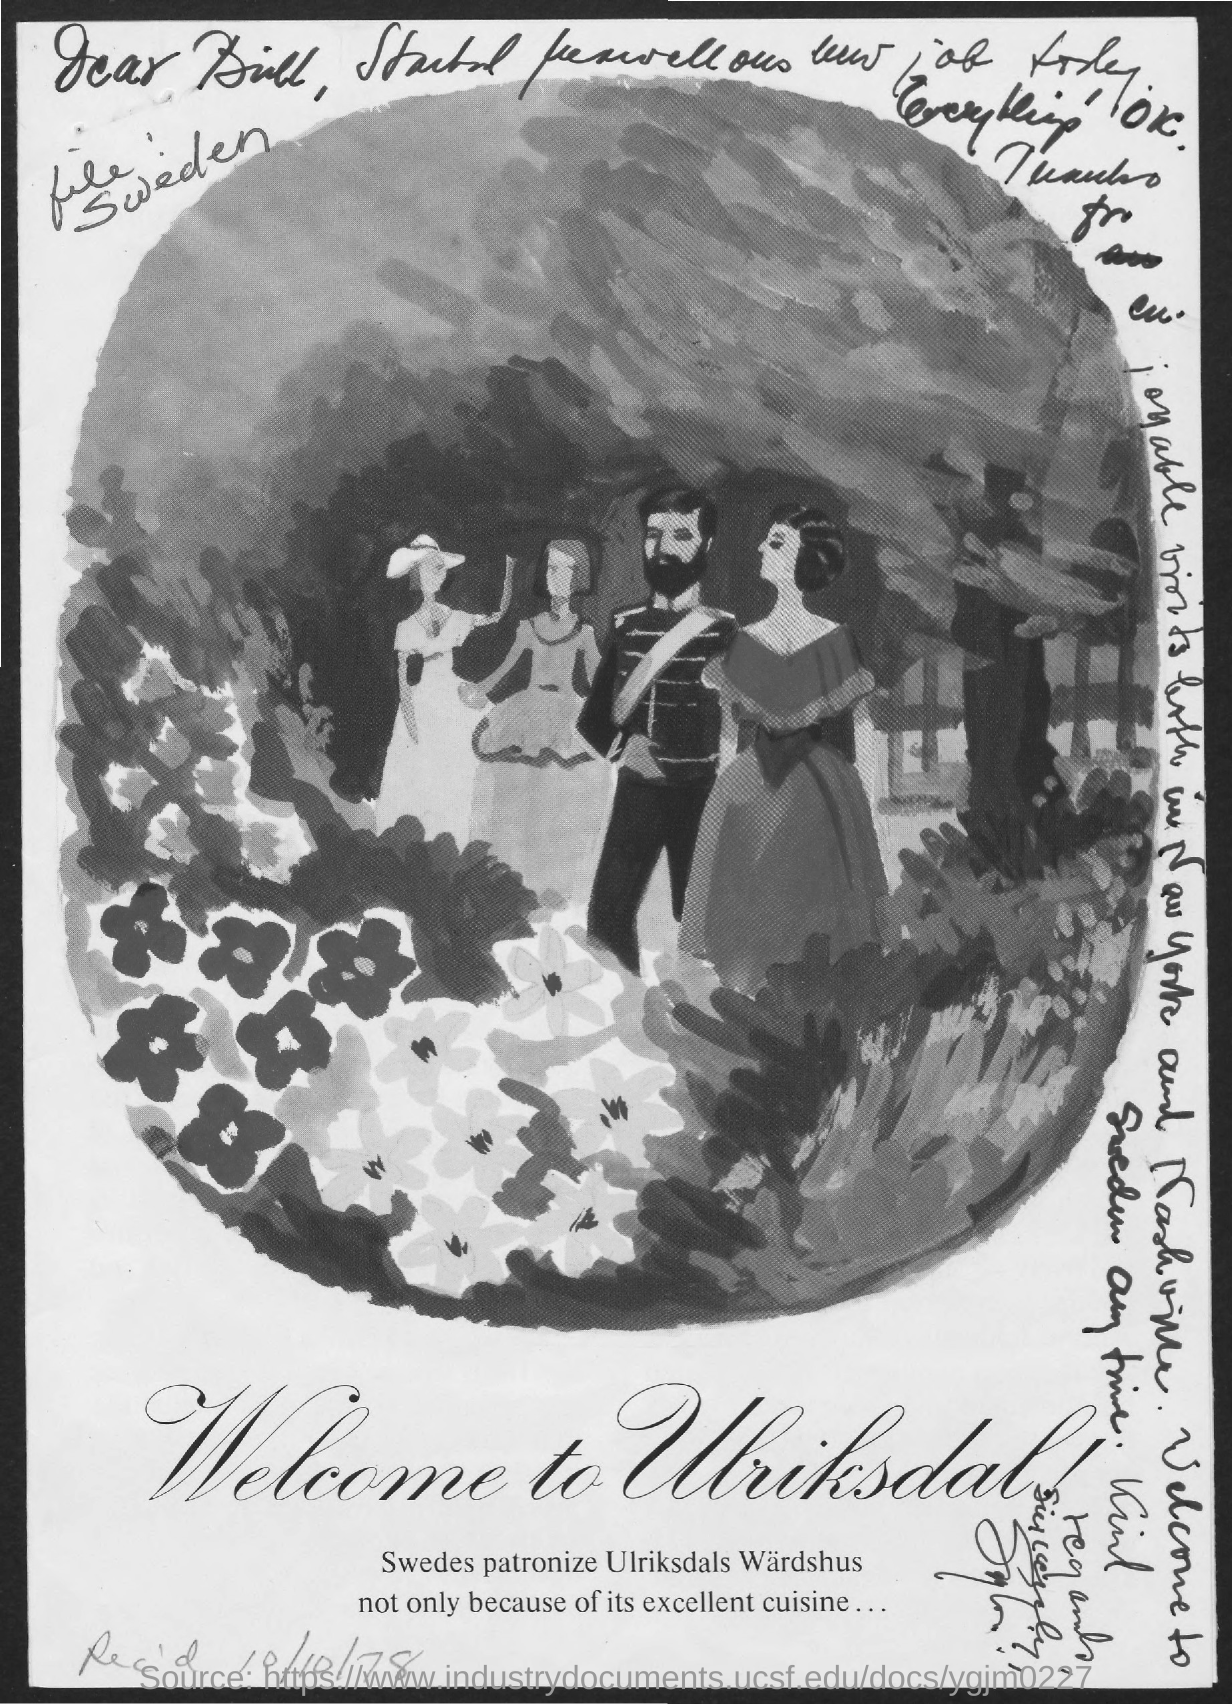Draw attention to some important aspects in this diagram. The image below contains text that reads, 'Welcome to Ulriksdal!' 